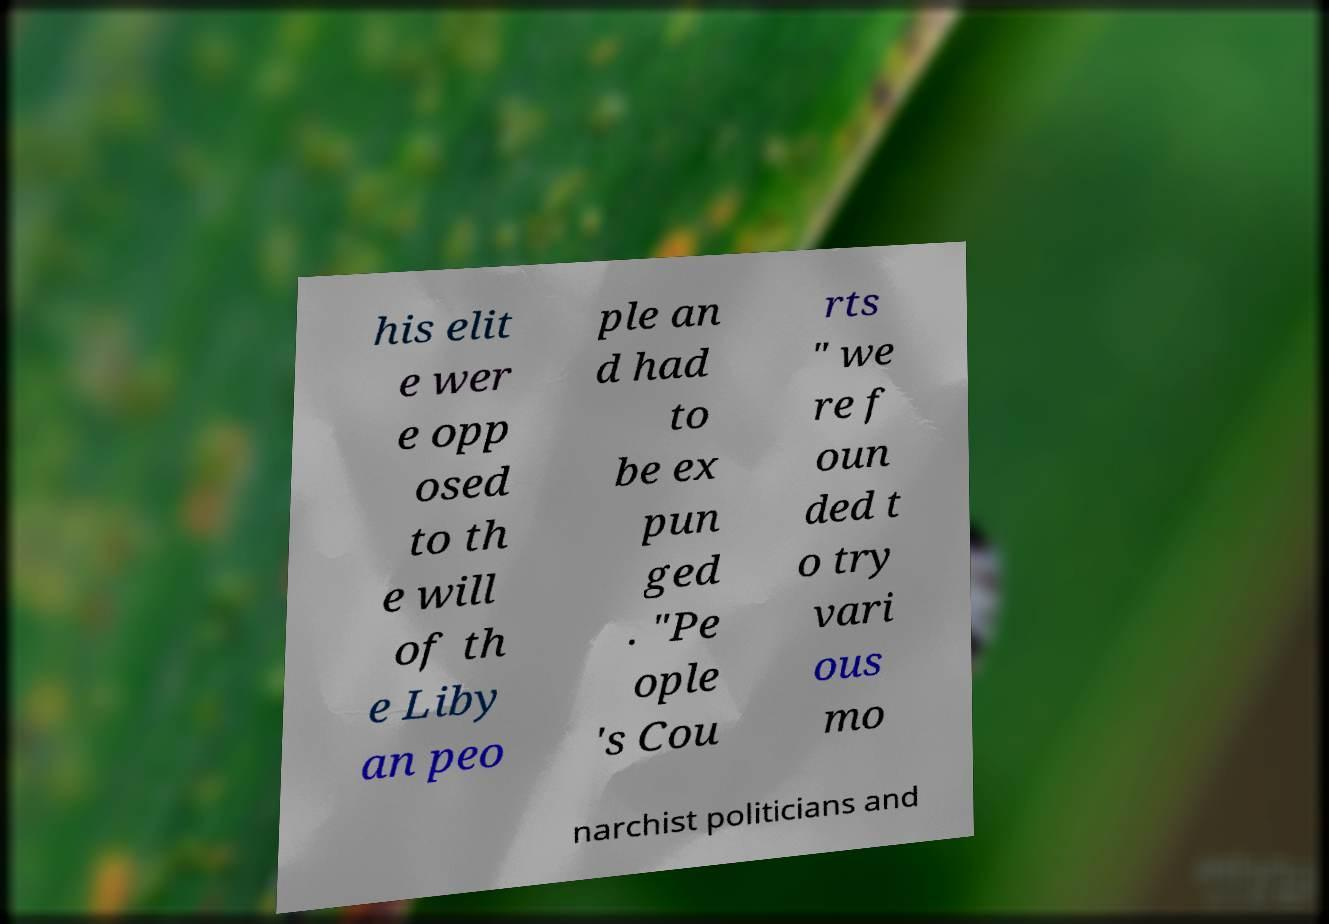What messages or text are displayed in this image? I need them in a readable, typed format. his elit e wer e opp osed to th e will of th e Liby an peo ple an d had to be ex pun ged . "Pe ople 's Cou rts " we re f oun ded t o try vari ous mo narchist politicians and 